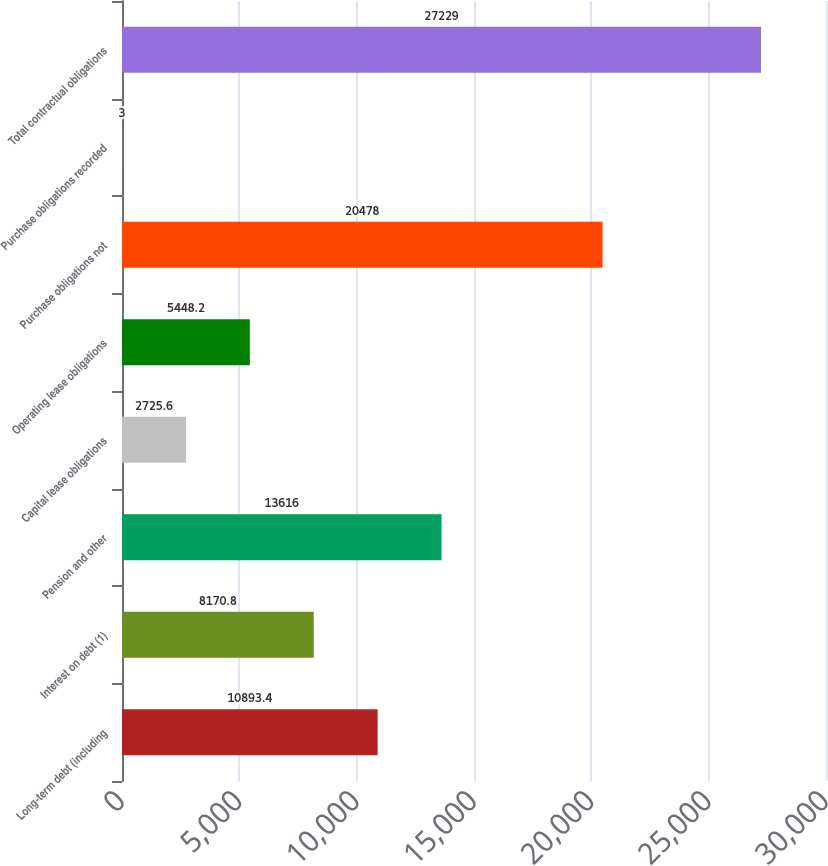Convert chart. <chart><loc_0><loc_0><loc_500><loc_500><bar_chart><fcel>Long-term debt (including<fcel>Interest on debt (1)<fcel>Pension and other<fcel>Capital lease obligations<fcel>Operating lease obligations<fcel>Purchase obligations not<fcel>Purchase obligations recorded<fcel>Total contractual obligations<nl><fcel>10893.4<fcel>8170.8<fcel>13616<fcel>2725.6<fcel>5448.2<fcel>20478<fcel>3<fcel>27229<nl></chart> 